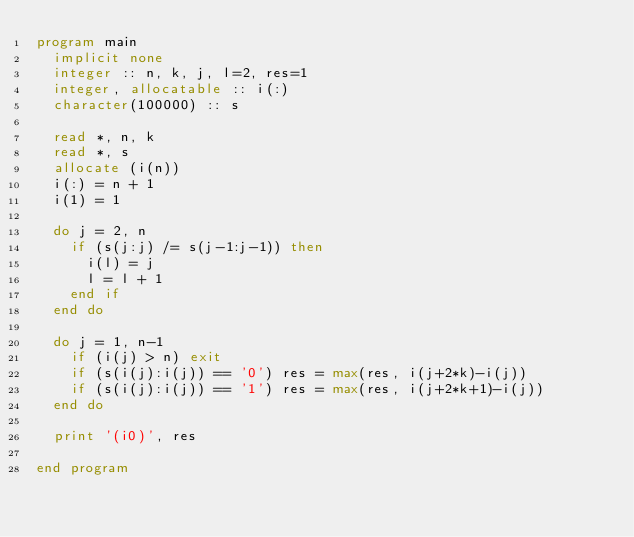<code> <loc_0><loc_0><loc_500><loc_500><_FORTRAN_>program main
  implicit none
  integer :: n, k, j, l=2, res=1
  integer, allocatable :: i(:)
  character(100000) :: s

  read *, n, k
  read *, s
  allocate (i(n))
  i(:) = n + 1
  i(1) = 1

  do j = 2, n
    if (s(j:j) /= s(j-1:j-1)) then
      i(l) = j
      l = l + 1
    end if
  end do

  do j = 1, n-1
    if (i(j) > n) exit
    if (s(i(j):i(j)) == '0') res = max(res, i(j+2*k)-i(j))
    if (s(i(j):i(j)) == '1') res = max(res, i(j+2*k+1)-i(j))
  end do

  print '(i0)', res

end program</code> 